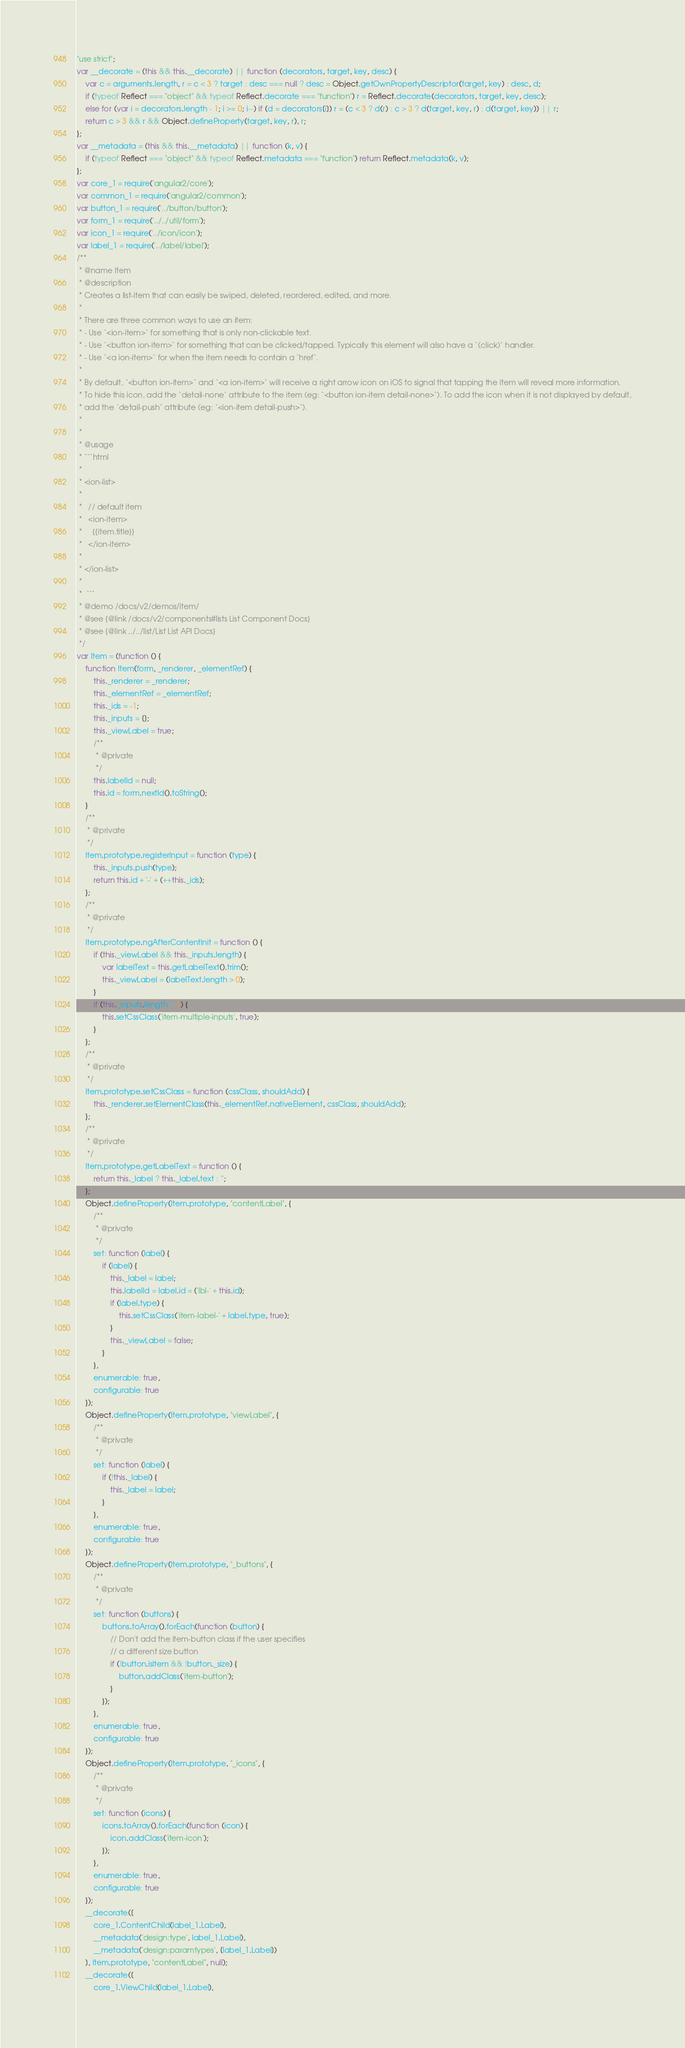<code> <loc_0><loc_0><loc_500><loc_500><_JavaScript_>"use strict";
var __decorate = (this && this.__decorate) || function (decorators, target, key, desc) {
    var c = arguments.length, r = c < 3 ? target : desc === null ? desc = Object.getOwnPropertyDescriptor(target, key) : desc, d;
    if (typeof Reflect === "object" && typeof Reflect.decorate === "function") r = Reflect.decorate(decorators, target, key, desc);
    else for (var i = decorators.length - 1; i >= 0; i--) if (d = decorators[i]) r = (c < 3 ? d(r) : c > 3 ? d(target, key, r) : d(target, key)) || r;
    return c > 3 && r && Object.defineProperty(target, key, r), r;
};
var __metadata = (this && this.__metadata) || function (k, v) {
    if (typeof Reflect === "object" && typeof Reflect.metadata === "function") return Reflect.metadata(k, v);
};
var core_1 = require('angular2/core');
var common_1 = require('angular2/common');
var button_1 = require('../button/button');
var form_1 = require('../../util/form');
var icon_1 = require('../icon/icon');
var label_1 = require('../label/label');
/**
 * @name Item
 * @description
 * Creates a list-item that can easily be swiped, deleted, reordered, edited, and more.
 *
 * There are three common ways to use an item:
 * - Use `<ion-item>` for something that is only non-clickable text.
 * - Use `<button ion-item>` for something that can be clicked/tapped. Typically this element will also have a `(click)` handler.
 * - Use `<a ion-item>` for when the item needs to contain a `href`.
 *
 * By default, `<button ion-item>` and `<a ion-item>` will receive a right arrow icon on iOS to signal that tapping the item will reveal more information.
 * To hide this icon, add the `detail-none` attribute to the item (eg: `<button ion-item detail-none>`). To add the icon when it is not displayed by default,
 * add the `detail-push` attribute (eg: `<ion-item detail-push>`).
 *
 *
 * @usage
 * ```html
 *
 * <ion-list>
 *
 *   // default item
 *   <ion-item>
 *     {{item.title}}
 *   </ion-item>
 *
 * </ion-list>
 *
 *  ```
 * @demo /docs/v2/demos/item/
 * @see {@link /docs/v2/components#lists List Component Docs}
 * @see {@link ../../list/List List API Docs}
 */
var Item = (function () {
    function Item(form, _renderer, _elementRef) {
        this._renderer = _renderer;
        this._elementRef = _elementRef;
        this._ids = -1;
        this._inputs = [];
        this._viewLabel = true;
        /**
         * @private
         */
        this.labelId = null;
        this.id = form.nextId().toString();
    }
    /**
     * @private
     */
    Item.prototype.registerInput = function (type) {
        this._inputs.push(type);
        return this.id + '-' + (++this._ids);
    };
    /**
     * @private
     */
    Item.prototype.ngAfterContentInit = function () {
        if (this._viewLabel && this._inputs.length) {
            var labelText = this.getLabelText().trim();
            this._viewLabel = (labelText.length > 0);
        }
        if (this._inputs.length > 1) {
            this.setCssClass('item-multiple-inputs', true);
        }
    };
    /**
     * @private
     */
    Item.prototype.setCssClass = function (cssClass, shouldAdd) {
        this._renderer.setElementClass(this._elementRef.nativeElement, cssClass, shouldAdd);
    };
    /**
     * @private
     */
    Item.prototype.getLabelText = function () {
        return this._label ? this._label.text : '';
    };
    Object.defineProperty(Item.prototype, "contentLabel", {
        /**
         * @private
         */
        set: function (label) {
            if (label) {
                this._label = label;
                this.labelId = label.id = ('lbl-' + this.id);
                if (label.type) {
                    this.setCssClass('item-label-' + label.type, true);
                }
                this._viewLabel = false;
            }
        },
        enumerable: true,
        configurable: true
    });
    Object.defineProperty(Item.prototype, "viewLabel", {
        /**
         * @private
         */
        set: function (label) {
            if (!this._label) {
                this._label = label;
            }
        },
        enumerable: true,
        configurable: true
    });
    Object.defineProperty(Item.prototype, "_buttons", {
        /**
         * @private
         */
        set: function (buttons) {
            buttons.toArray().forEach(function (button) {
                // Don't add the item-button class if the user specifies
                // a different size button
                if (!button.isItem && !button._size) {
                    button.addClass('item-button');
                }
            });
        },
        enumerable: true,
        configurable: true
    });
    Object.defineProperty(Item.prototype, "_icons", {
        /**
         * @private
         */
        set: function (icons) {
            icons.toArray().forEach(function (icon) {
                icon.addClass('item-icon');
            });
        },
        enumerable: true,
        configurable: true
    });
    __decorate([
        core_1.ContentChild(label_1.Label), 
        __metadata('design:type', label_1.Label), 
        __metadata('design:paramtypes', [label_1.Label])
    ], Item.prototype, "contentLabel", null);
    __decorate([
        core_1.ViewChild(label_1.Label), </code> 